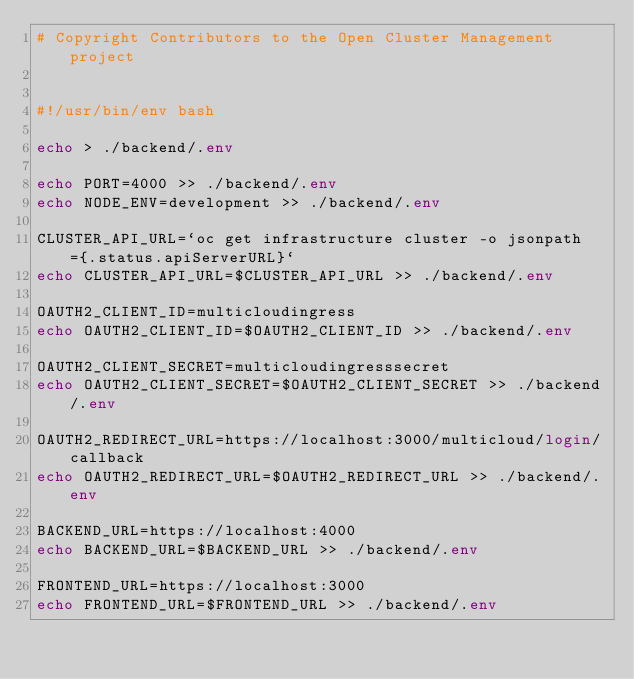<code> <loc_0><loc_0><loc_500><loc_500><_Bash_># Copyright Contributors to the Open Cluster Management project


#!/usr/bin/env bash

echo > ./backend/.env

echo PORT=4000 >> ./backend/.env
echo NODE_ENV=development >> ./backend/.env

CLUSTER_API_URL=`oc get infrastructure cluster -o jsonpath={.status.apiServerURL}`
echo CLUSTER_API_URL=$CLUSTER_API_URL >> ./backend/.env

OAUTH2_CLIENT_ID=multicloudingress
echo OAUTH2_CLIENT_ID=$OAUTH2_CLIENT_ID >> ./backend/.env

OAUTH2_CLIENT_SECRET=multicloudingresssecret
echo OAUTH2_CLIENT_SECRET=$OAUTH2_CLIENT_SECRET >> ./backend/.env

OAUTH2_REDIRECT_URL=https://localhost:3000/multicloud/login/callback
echo OAUTH2_REDIRECT_URL=$OAUTH2_REDIRECT_URL >> ./backend/.env

BACKEND_URL=https://localhost:4000
echo BACKEND_URL=$BACKEND_URL >> ./backend/.env

FRONTEND_URL=https://localhost:3000
echo FRONTEND_URL=$FRONTEND_URL >> ./backend/.env
</code> 